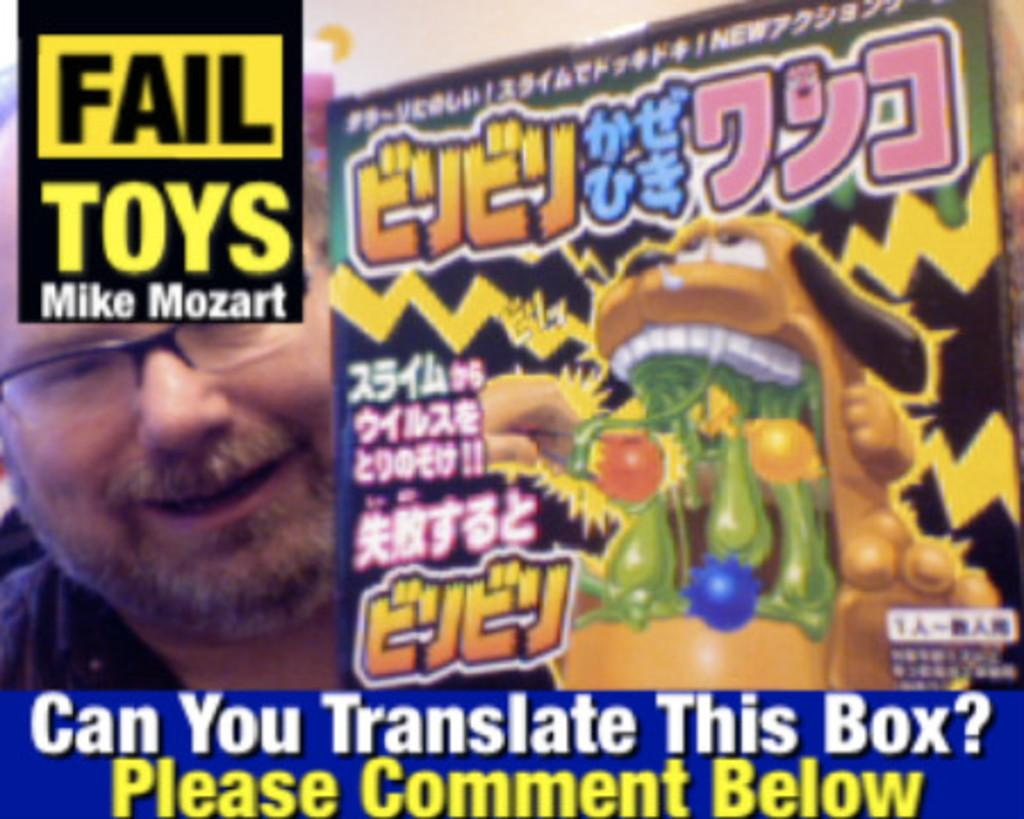Who is present in the image? There is a man in the image. What is the man wearing? The man is wearing spectacles. What type of images can be seen in the image? There are cartoon images in the image. Is there any text present in the image? Yes, there is text written on the image. What type of destruction can be seen happening to the church in the image? There is no church present in the image, nor is there any destruction depicted. 